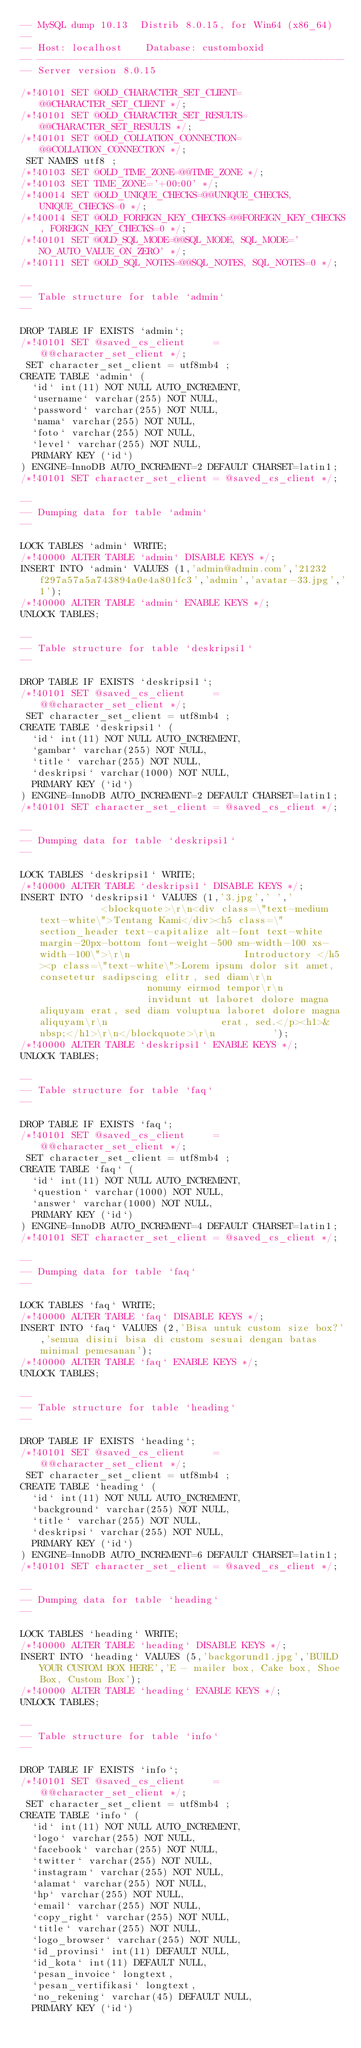<code> <loc_0><loc_0><loc_500><loc_500><_SQL_>-- MySQL dump 10.13  Distrib 8.0.15, for Win64 (x86_64)
--
-- Host: localhost    Database: customboxid
-- ------------------------------------------------------
-- Server version	8.0.15

/*!40101 SET @OLD_CHARACTER_SET_CLIENT=@@CHARACTER_SET_CLIENT */;
/*!40101 SET @OLD_CHARACTER_SET_RESULTS=@@CHARACTER_SET_RESULTS */;
/*!40101 SET @OLD_COLLATION_CONNECTION=@@COLLATION_CONNECTION */;
 SET NAMES utf8 ;
/*!40103 SET @OLD_TIME_ZONE=@@TIME_ZONE */;
/*!40103 SET TIME_ZONE='+00:00' */;
/*!40014 SET @OLD_UNIQUE_CHECKS=@@UNIQUE_CHECKS, UNIQUE_CHECKS=0 */;
/*!40014 SET @OLD_FOREIGN_KEY_CHECKS=@@FOREIGN_KEY_CHECKS, FOREIGN_KEY_CHECKS=0 */;
/*!40101 SET @OLD_SQL_MODE=@@SQL_MODE, SQL_MODE='NO_AUTO_VALUE_ON_ZERO' */;
/*!40111 SET @OLD_SQL_NOTES=@@SQL_NOTES, SQL_NOTES=0 */;

--
-- Table structure for table `admin`
--

DROP TABLE IF EXISTS `admin`;
/*!40101 SET @saved_cs_client     = @@character_set_client */;
 SET character_set_client = utf8mb4 ;
CREATE TABLE `admin` (
  `id` int(11) NOT NULL AUTO_INCREMENT,
  `username` varchar(255) NOT NULL,
  `password` varchar(255) NOT NULL,
  `nama` varchar(255) NOT NULL,
  `foto` varchar(255) NOT NULL,
  `level` varchar(255) NOT NULL,
  PRIMARY KEY (`id`)
) ENGINE=InnoDB AUTO_INCREMENT=2 DEFAULT CHARSET=latin1;
/*!40101 SET character_set_client = @saved_cs_client */;

--
-- Dumping data for table `admin`
--

LOCK TABLES `admin` WRITE;
/*!40000 ALTER TABLE `admin` DISABLE KEYS */;
INSERT INTO `admin` VALUES (1,'admin@admin.com','21232f297a57a5a743894a0e4a801fc3','admin','avatar-33.jpg','1');
/*!40000 ALTER TABLE `admin` ENABLE KEYS */;
UNLOCK TABLES;

--
-- Table structure for table `deskripsi1`
--

DROP TABLE IF EXISTS `deskripsi1`;
/*!40101 SET @saved_cs_client     = @@character_set_client */;
 SET character_set_client = utf8mb4 ;
CREATE TABLE `deskripsi1` (
  `id` int(11) NOT NULL AUTO_INCREMENT,
  `gambar` varchar(255) NOT NULL,
  `title` varchar(255) NOT NULL,
  `deskripsi` varchar(1000) NOT NULL,
  PRIMARY KEY (`id`)
) ENGINE=InnoDB AUTO_INCREMENT=2 DEFAULT CHARSET=latin1;
/*!40101 SET character_set_client = @saved_cs_client */;

--
-- Dumping data for table `deskripsi1`
--

LOCK TABLES `deskripsi1` WRITE;
/*!40000 ALTER TABLE `deskripsi1` DISABLE KEYS */;
INSERT INTO `deskripsi1` VALUES (1,'3.jpg',' ','            <blockquote>\r\n<div class=\"text-medium text-white\">Tentang Kami</div><h5 class=\"section_header text-capitalize alt-font text-white margin-20px-bottom font-weight-500 sm-width-100 xs-width-100\">\r\n                    Introductory </h5><p class=\"text-white\">Lorem ipsum dolor sit amet, consetetur sadipscing elitr, sed diam\r\n                    nonumy eirmod tempor\r\n                    invidunt ut laboret dolore magna aliquyam erat, sed diam voluptua laboret dolore magna aliquyam\r\n                    erat, sed.</p><h1>&nbsp;</h1>\r\n</blockquote>\r\n          ');
/*!40000 ALTER TABLE `deskripsi1` ENABLE KEYS */;
UNLOCK TABLES;

--
-- Table structure for table `faq`
--

DROP TABLE IF EXISTS `faq`;
/*!40101 SET @saved_cs_client     = @@character_set_client */;
 SET character_set_client = utf8mb4 ;
CREATE TABLE `faq` (
  `id` int(11) NOT NULL AUTO_INCREMENT,
  `question` varchar(1000) NOT NULL,
  `answer` varchar(1000) NOT NULL,
  PRIMARY KEY (`id`)
) ENGINE=InnoDB AUTO_INCREMENT=4 DEFAULT CHARSET=latin1;
/*!40101 SET character_set_client = @saved_cs_client */;

--
-- Dumping data for table `faq`
--

LOCK TABLES `faq` WRITE;
/*!40000 ALTER TABLE `faq` DISABLE KEYS */;
INSERT INTO `faq` VALUES (2,'Bisa untuk custom size box?','semua disini bisa di custom sesuai dengan batas minimal pemesanan');
/*!40000 ALTER TABLE `faq` ENABLE KEYS */;
UNLOCK TABLES;

--
-- Table structure for table `heading`
--

DROP TABLE IF EXISTS `heading`;
/*!40101 SET @saved_cs_client     = @@character_set_client */;
 SET character_set_client = utf8mb4 ;
CREATE TABLE `heading` (
  `id` int(11) NOT NULL AUTO_INCREMENT,
  `background` varchar(255) NOT NULL,
  `title` varchar(255) NOT NULL,
  `deskripsi` varchar(255) NOT NULL,
  PRIMARY KEY (`id`)
) ENGINE=InnoDB AUTO_INCREMENT=6 DEFAULT CHARSET=latin1;
/*!40101 SET character_set_client = @saved_cs_client */;

--
-- Dumping data for table `heading`
--

LOCK TABLES `heading` WRITE;
/*!40000 ALTER TABLE `heading` DISABLE KEYS */;
INSERT INTO `heading` VALUES (5,'backgorund1.jpg','BUILD YOUR CUSTOM BOX HERE','E - mailer box, Cake box, Shoe Box, Custom Box');
/*!40000 ALTER TABLE `heading` ENABLE KEYS */;
UNLOCK TABLES;

--
-- Table structure for table `info`
--

DROP TABLE IF EXISTS `info`;
/*!40101 SET @saved_cs_client     = @@character_set_client */;
 SET character_set_client = utf8mb4 ;
CREATE TABLE `info` (
  `id` int(11) NOT NULL AUTO_INCREMENT,
  `logo` varchar(255) NOT NULL,
  `facebook` varchar(255) NOT NULL,
  `twitter` varchar(255) NOT NULL,
  `instagram` varchar(255) NOT NULL,
  `alamat` varchar(255) NOT NULL,
  `hp` varchar(255) NOT NULL,
  `email` varchar(255) NOT NULL,
  `copy_right` varchar(255) NOT NULL,
  `title` varchar(255) NOT NULL,
  `logo_browser` varchar(255) NOT NULL,
  `id_provinsi` int(11) DEFAULT NULL,
  `id_kota` int(11) DEFAULT NULL,
  `pesan_invoice` longtext,
  `pesan_vertifikasi` longtext,
  `no_rekening` varchar(45) DEFAULT NULL,
  PRIMARY KEY (`id`)</code> 